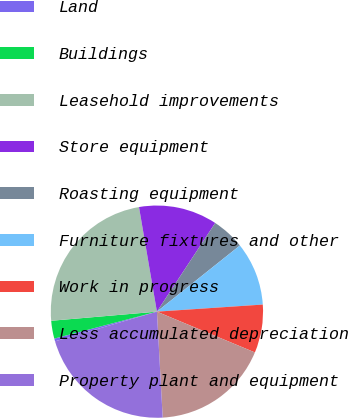<chart> <loc_0><loc_0><loc_500><loc_500><pie_chart><fcel>Land<fcel>Buildings<fcel>Leasehold improvements<fcel>Store equipment<fcel>Roasting equipment<fcel>Furniture fixtures and other<fcel>Work in progress<fcel>Less accumulated depreciation<fcel>Property plant and equipment<nl><fcel>0.42%<fcel>2.72%<fcel>23.67%<fcel>11.96%<fcel>5.03%<fcel>9.65%<fcel>7.34%<fcel>17.86%<fcel>21.36%<nl></chart> 